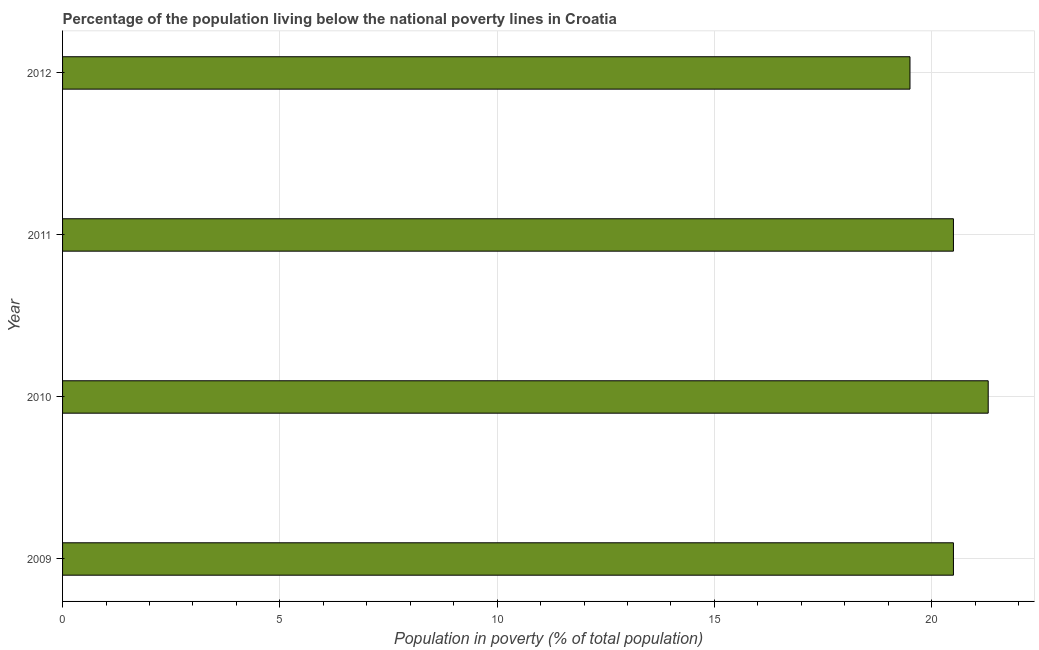What is the title of the graph?
Offer a very short reply. Percentage of the population living below the national poverty lines in Croatia. What is the label or title of the X-axis?
Make the answer very short. Population in poverty (% of total population). What is the label or title of the Y-axis?
Your answer should be very brief. Year. What is the percentage of population living below poverty line in 2012?
Make the answer very short. 19.5. Across all years, what is the maximum percentage of population living below poverty line?
Keep it short and to the point. 21.3. Across all years, what is the minimum percentage of population living below poverty line?
Your answer should be compact. 19.5. What is the sum of the percentage of population living below poverty line?
Make the answer very short. 81.8. What is the difference between the percentage of population living below poverty line in 2010 and 2012?
Offer a terse response. 1.8. What is the average percentage of population living below poverty line per year?
Offer a terse response. 20.45. What is the ratio of the percentage of population living below poverty line in 2010 to that in 2012?
Make the answer very short. 1.09. Is the percentage of population living below poverty line in 2010 less than that in 2011?
Your answer should be compact. No. Is the difference between the percentage of population living below poverty line in 2009 and 2011 greater than the difference between any two years?
Your answer should be compact. No. What is the difference between the highest and the second highest percentage of population living below poverty line?
Give a very brief answer. 0.8. In how many years, is the percentage of population living below poverty line greater than the average percentage of population living below poverty line taken over all years?
Your answer should be compact. 3. What is the Population in poverty (% of total population) in 2009?
Keep it short and to the point. 20.5. What is the Population in poverty (% of total population) of 2010?
Offer a very short reply. 21.3. What is the Population in poverty (% of total population) of 2011?
Your answer should be very brief. 20.5. What is the Population in poverty (% of total population) of 2012?
Offer a terse response. 19.5. What is the difference between the Population in poverty (% of total population) in 2009 and 2012?
Make the answer very short. 1. What is the ratio of the Population in poverty (% of total population) in 2009 to that in 2010?
Ensure brevity in your answer.  0.96. What is the ratio of the Population in poverty (% of total population) in 2009 to that in 2012?
Your answer should be very brief. 1.05. What is the ratio of the Population in poverty (% of total population) in 2010 to that in 2011?
Your answer should be very brief. 1.04. What is the ratio of the Population in poverty (% of total population) in 2010 to that in 2012?
Provide a succinct answer. 1.09. What is the ratio of the Population in poverty (% of total population) in 2011 to that in 2012?
Offer a very short reply. 1.05. 